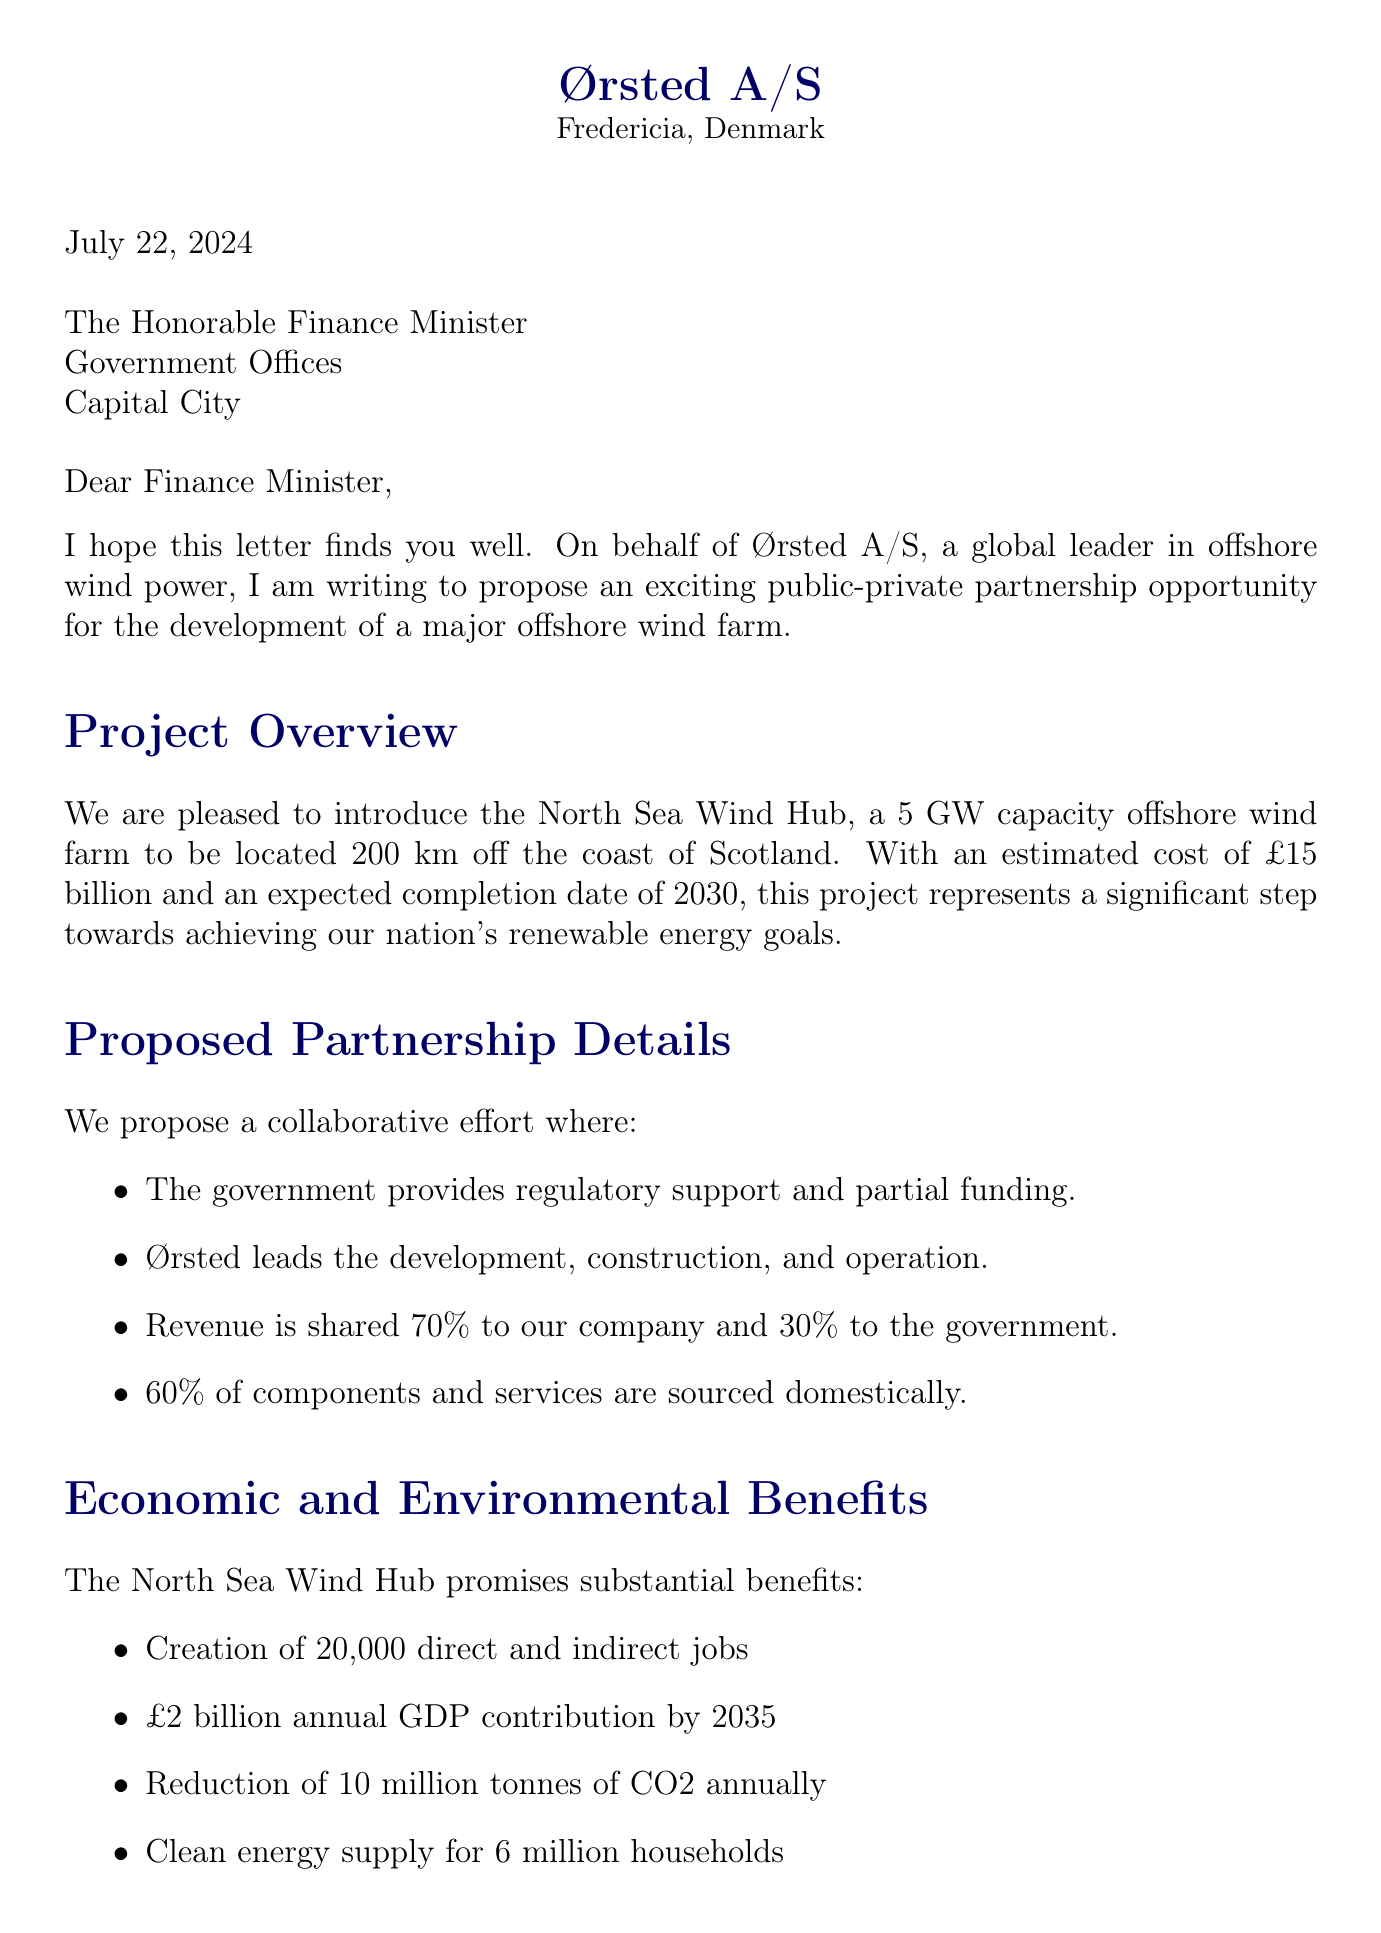What is the name of the project? The project name is mentioned under Project Overview in the letter.
Answer: North Sea Wind Hub What is the estimated cost of the project? The estimated cost is specifically stated in the Project Overview section.
Answer: £15 billion How much of the revenue will the government receive? The revenue sharing details are provided in the Proposed Partnership Details section.
Answer: 30% When is the construction expected to start? The timeline for construction start is outlined in the Timeline and Milestones section.
Answer: Q2 2025 What is the expected annual GDP contribution by 2035? The economic benefits include an annual GDP contribution mentioned in the Economic and Environmental Benefits section.
Answer: £2 billion How many direct and indirect jobs will be created? Job creation figures are presented in the Economic and Environmental Benefits section.
Answer: 20,000 What is Ørsted A/S's role in the partnership? The company’s responsibilities are listed in the Proposed Partnership Details section.
Answer: Lead development, construction, and operation What percentage of components and services must be sourced domestically? The local content requirement is noted in the Proposed Partnership Details section.
Answer: 60% What is the government's contribution to the funding structure? The details of the funding structure state the government's financial involvement.
Answer: £3 billion in grants and low-interest loans 